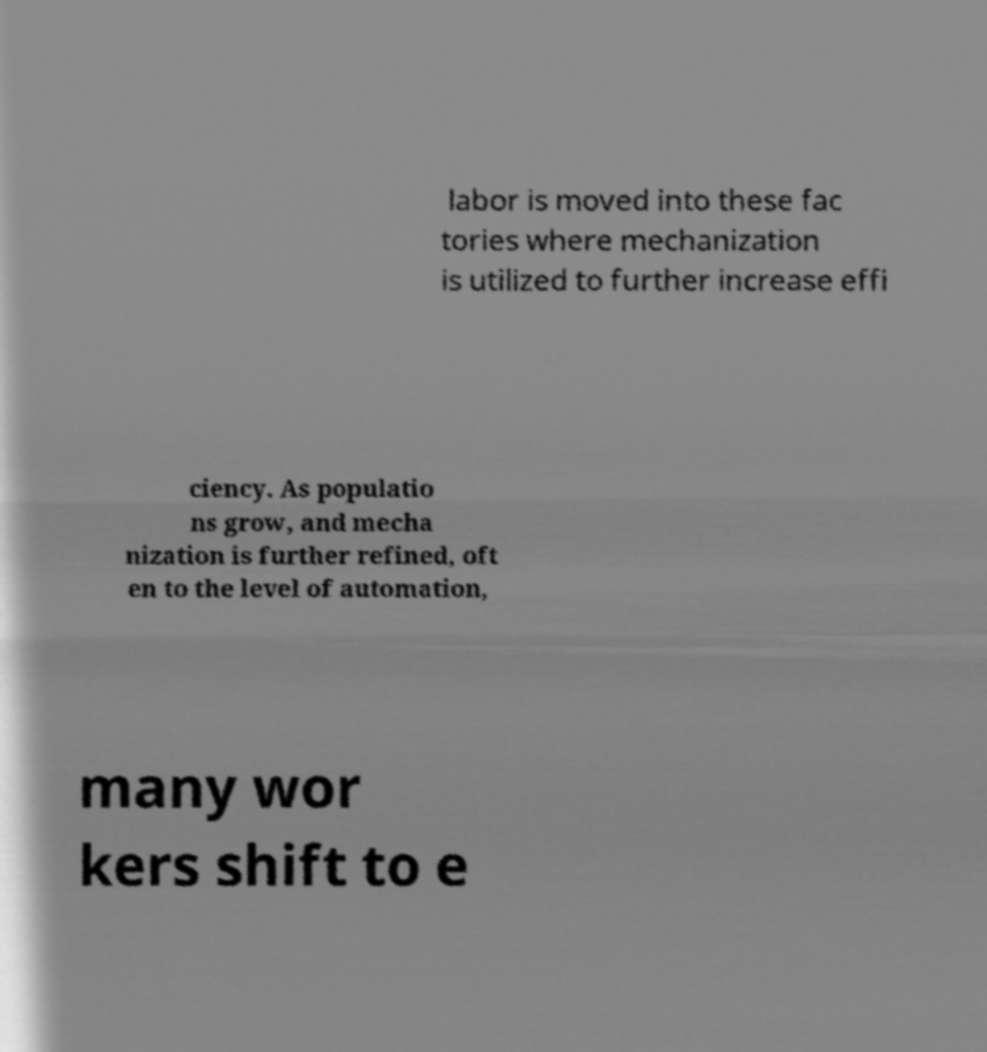Can you read and provide the text displayed in the image?This photo seems to have some interesting text. Can you extract and type it out for me? labor is moved into these fac tories where mechanization is utilized to further increase effi ciency. As populatio ns grow, and mecha nization is further refined, oft en to the level of automation, many wor kers shift to e 